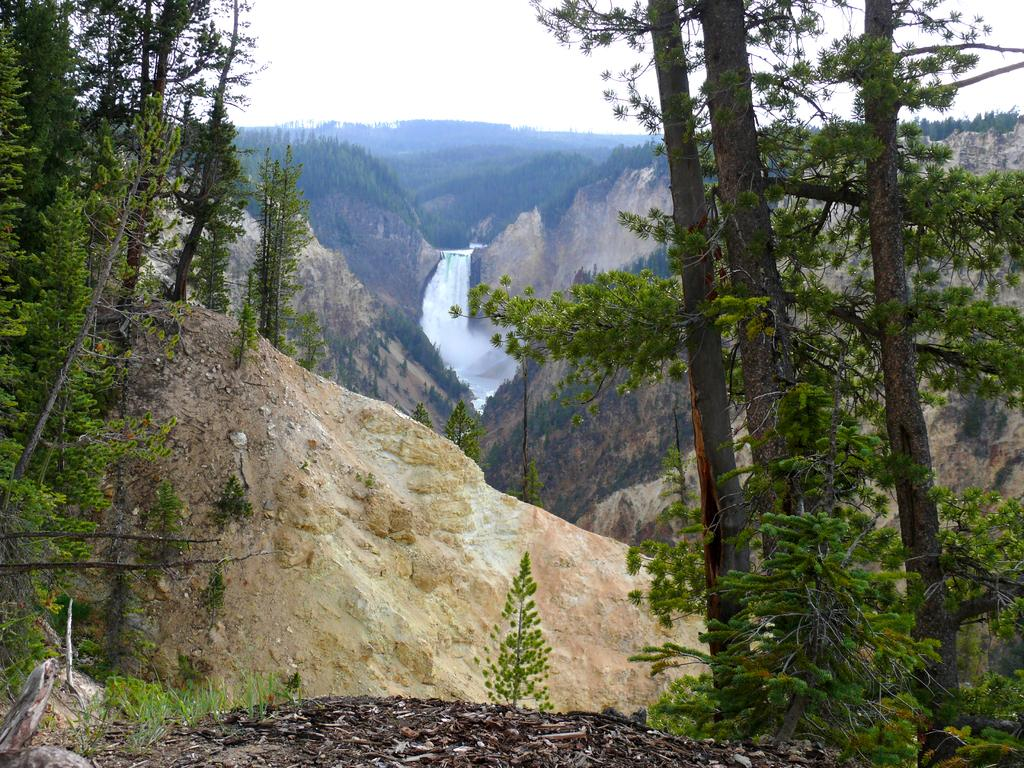What type of vegetation can be seen in the image? There are trees in the image. What natural feature is located in the middle of the image? There is a waterfall in the middle of the image. What type of landscape is visible in the image? There are hills visible in the image. What is visible in the background of the image? The sky is visible in the background of the image. How many spots can be seen on the waterfall in the image? There are no spots visible on the waterfall in the image. What type of plantation is present in the image? There is no plantation present in the image; it features trees, a waterfall, hills, and the sky. 